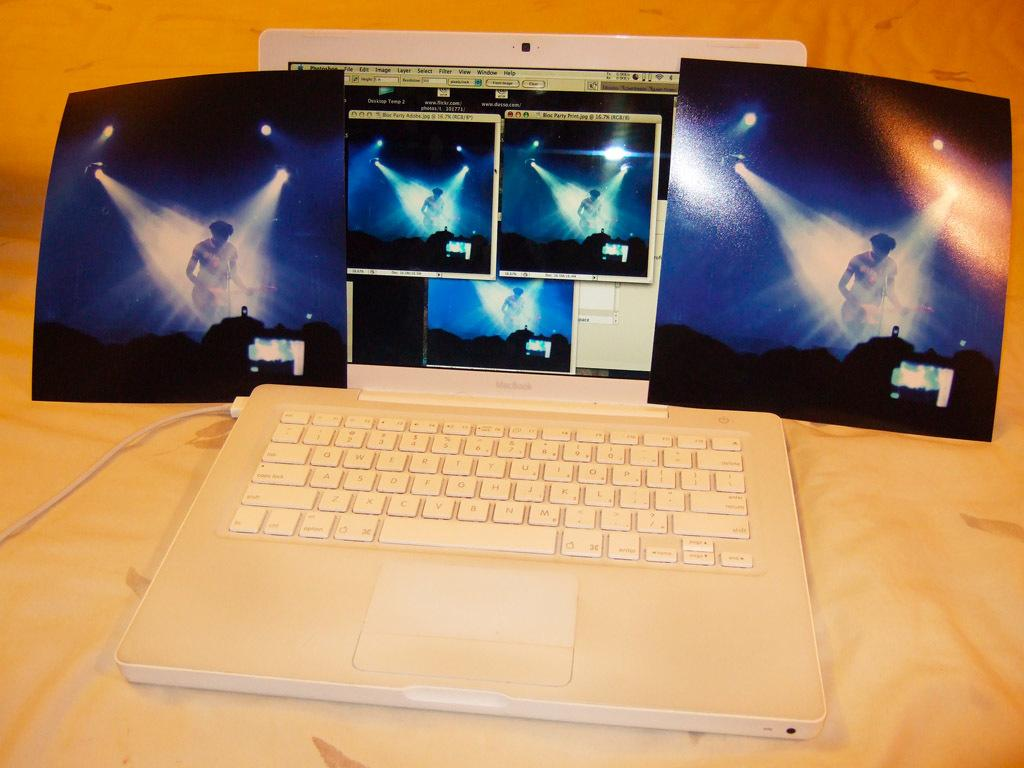Provide a one-sentence caption for the provided image. A white Macbook shows shots of a concert on the screen. 